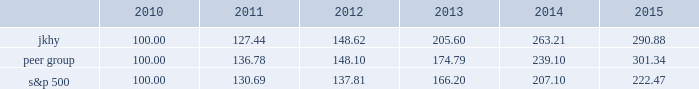18 2015 annual report performance graph the following chart presents a comparison for the five-year period ended june 30 , 2015 , of the market performance of the company 2019s common stock with the s&p 500 index and an index of peer companies selected by the company : comparison of 5 year cumulative total return among jack henry & associates , inc. , the s&p 500 index , and a peer group the following information depicts a line graph with the following values: .
This comparison assumes $ 100 was invested on june 30 , 2010 , and assumes reinvestments of dividends .
Total returns are calculated according to market capitalization of peer group members at the beginning of each period .
Peer companies selected are in the business of providing specialized computer software , hardware and related services to financial institutions and other businesses .
Companies in the peer group are aci worldwide , inc. , bottomline technology , inc. , broadridge financial solutions , cardtronics , inc. , convergys corp. , corelogic , inc. , dst systems , inc. , euronet worldwide , inc. , fair isaac corp. , fidelity national information services , inc. , fiserv , inc. , global payments , inc. , heartland payment systems , inc. , moneygram international , inc. , ss&c technologies holdings , inc. , total systems services , inc. , tyler technologies , inc. , verifone systems , inc. , and wex , inc. .
Micros systems , inc .
Was removed from the peer group as it was acquired in september 2014. .
What was the percentage change in the 5 year annual performance of the peer group stock from 2010 to 2011? 
Computations: ((148.10 - 136.78) / 136.78)
Answer: 0.08276. 